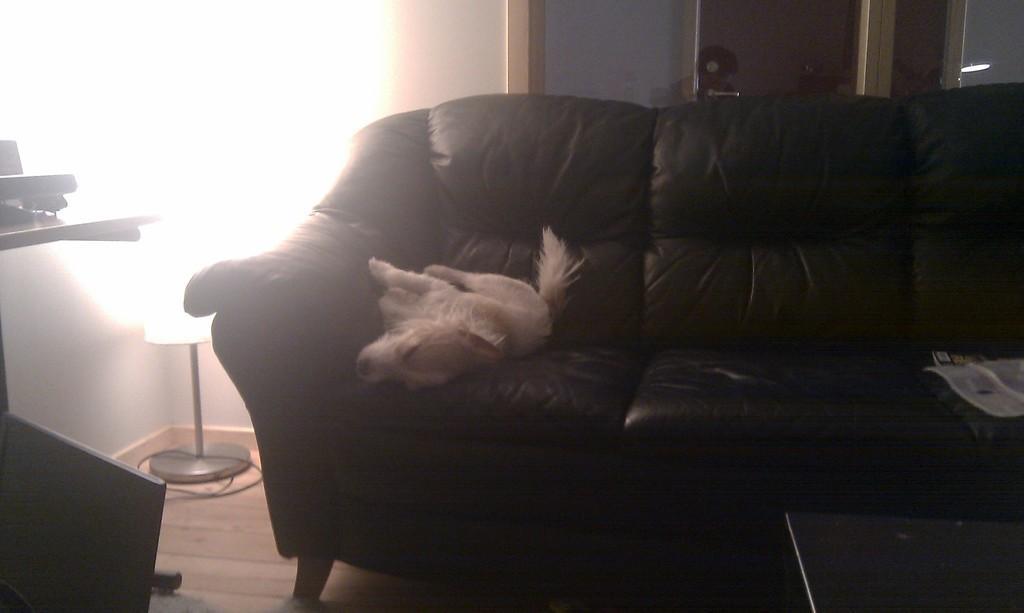How would you summarize this image in a sentence or two? This picture is clicked inside the room. In middle of picture, we see a black sofa on which a white dog is sleeping. Beside that, we see a lamp. Beside that, we see chair and behind the sofa, we see a white wall. 